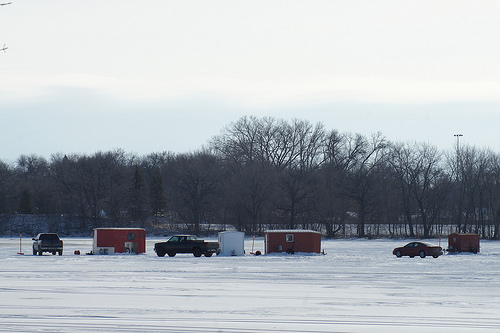<image>
Is the truck on the ground? Yes. Looking at the image, I can see the truck is positioned on top of the ground, with the ground providing support. 